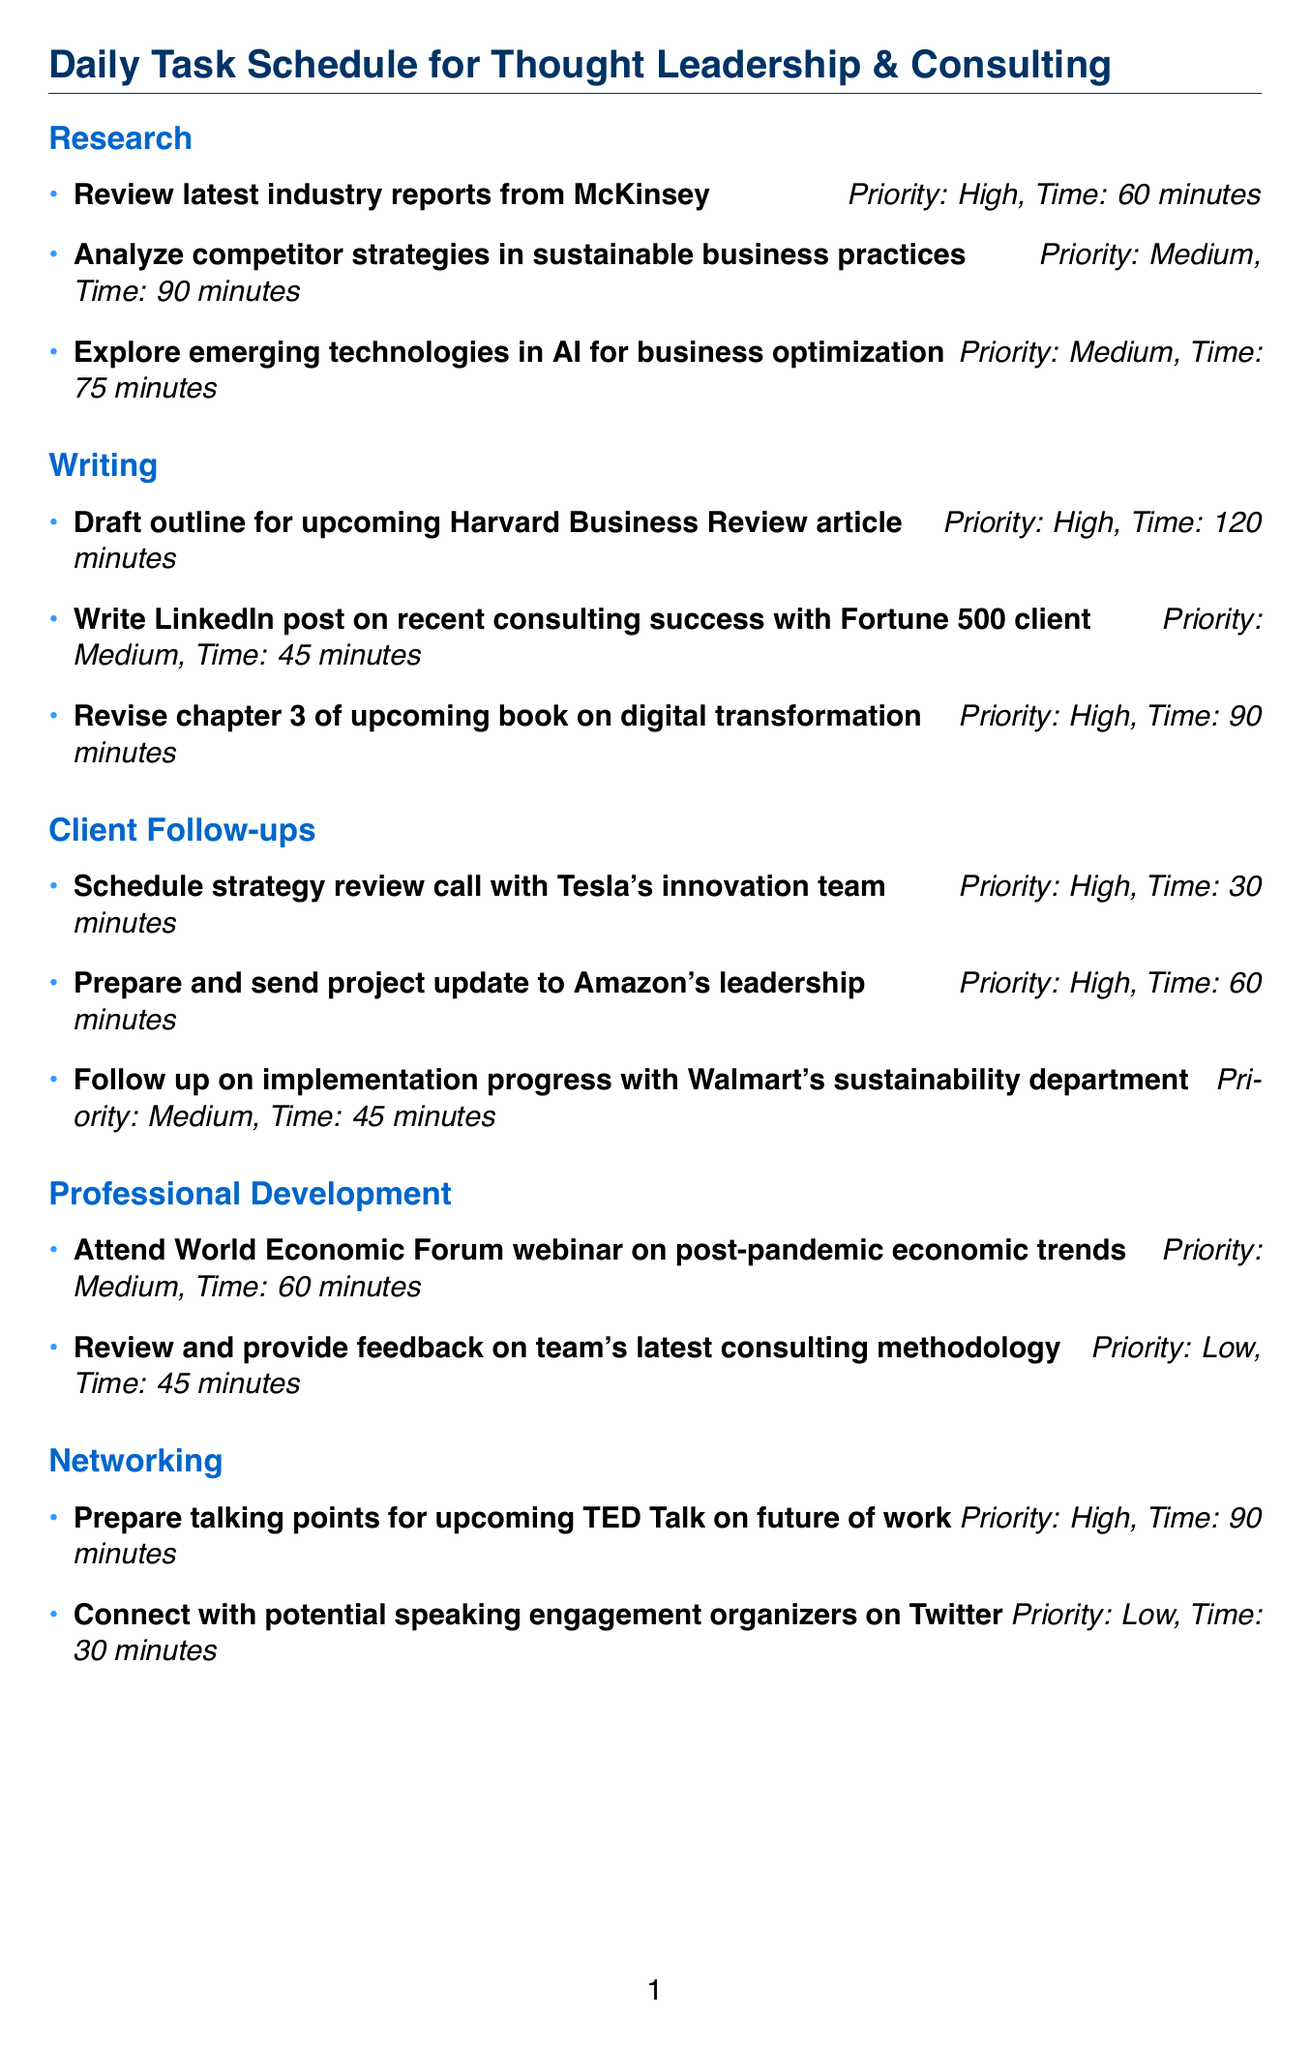What are the high-priority research tasks? The high-priority research tasks listed are "Review latest industry reports from McKinsey."
Answer: Review latest industry reports from McKinsey What is the estimated time for drafting the outline for the Harvard Business Review article? The document states that the estimated time for drafting the article outline is 120 minutes.
Answer: 120 minutes How many total high-priority tasks are present in the schedule? The schedule lists six high-priority tasks across different categories.
Answer: 6 What category includes a task related to communicating with Tesla? The task to schedule a strategy review call with Tesla's innovation team falls under the "Client Follow-ups" category.
Answer: Client Follow-ups Which category has the least number of tasks? "Professional Development" has only two tasks compared to others that have more.
Answer: Professional Development What is the total estimated time for medium-priority tasks? The document indicates that the total estimated time for medium-priority tasks is 315 minutes.
Answer: 315 minutes What task has the highest estimated time in writing? The task "Draft outline for upcoming Harvard Business Review article" has the highest estimated time of 120 minutes.
Answer: Draft outline for upcoming Harvard Business Review article Which networking task is deemed low-priority? The task "Connect with potential speaking engagement organizers on Twitter" is labeled as low-priority.
Answer: Connect with potential speaking engagement organizers on Twitter How many total minutes are allocated to high-priority tasks? The total time allocated to high-priority tasks is noted as 450 minutes in the summary table.
Answer: 450 minutes 